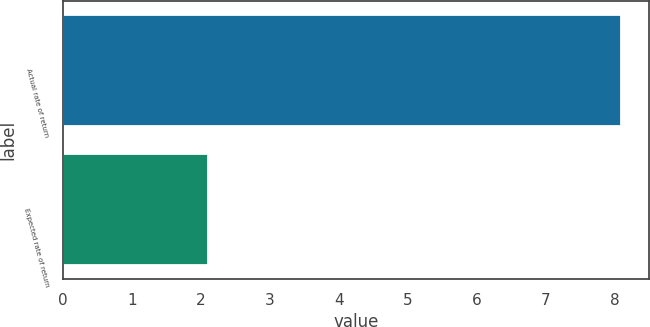Convert chart. <chart><loc_0><loc_0><loc_500><loc_500><bar_chart><fcel>Actual rate of return<fcel>Expected rate of return<nl><fcel>8.1<fcel>2.1<nl></chart> 